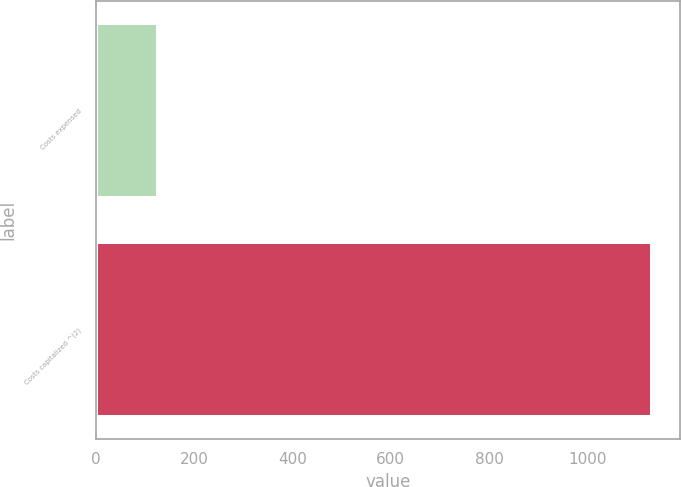Convert chart. <chart><loc_0><loc_0><loc_500><loc_500><bar_chart><fcel>Costs expensed<fcel>Costs capitalized ^(2)<nl><fcel>126<fcel>1132<nl></chart> 